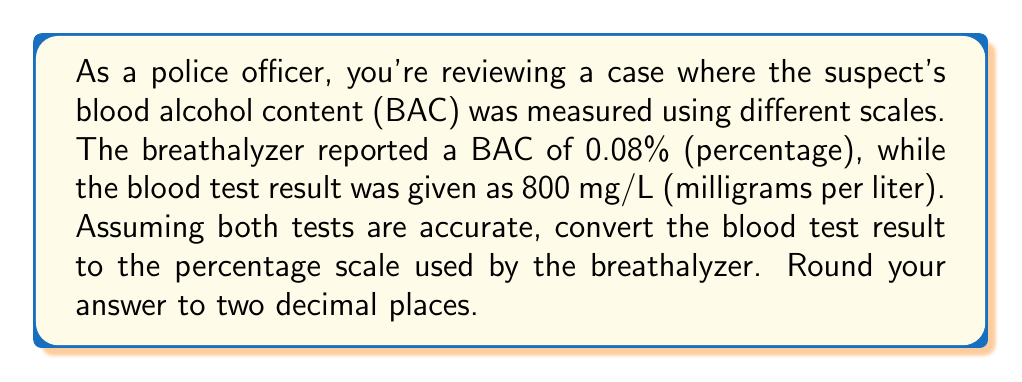Could you help me with this problem? To solve this problem, we need to understand the relationship between the different scales used to measure blood alcohol content:

1. The breathalyzer uses a percentage scale, where 0.08% = 0.0008 in decimal form.
2. The blood test uses milligrams per liter (mg/L).

The conversion factor between these scales is:
1 mg/L = 0.0001%

To convert 800 mg/L to a percentage:

$$\begin{align}
\text{BAC}_{\%} &= 800 \text{ mg/L} \times \frac{0.0001\%}{1 \text{ mg/L}} \\[10pt]
&= 800 \times 0.0001\% \\[10pt]
&= 0.08\%
\end{align}$$

Rounding to two decimal places, we get 0.08%.

This conversion shows that both the breathalyzer and blood test results are consistent, reporting the same BAC using different scales.
Answer: 0.08% 